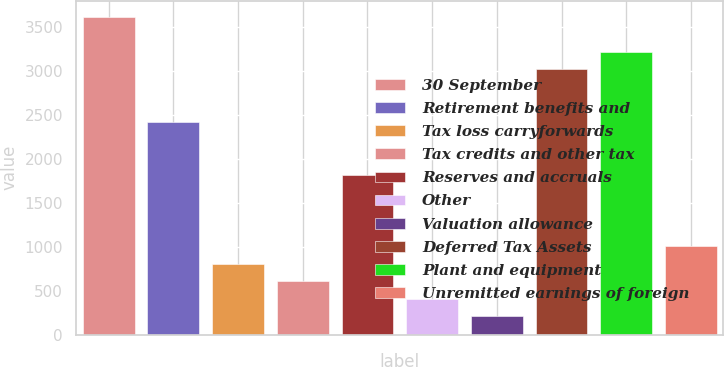Convert chart to OTSL. <chart><loc_0><loc_0><loc_500><loc_500><bar_chart><fcel>30 September<fcel>Retirement benefits and<fcel>Tax loss carryforwards<fcel>Tax credits and other tax<fcel>Reserves and accruals<fcel>Other<fcel>Valuation allowance<fcel>Deferred Tax Assets<fcel>Plant and equipment<fcel>Unremitted earnings of foreign<nl><fcel>3615.52<fcel>2412.88<fcel>809.36<fcel>608.92<fcel>1811.56<fcel>408.48<fcel>208.04<fcel>3014.2<fcel>3214.64<fcel>1009.8<nl></chart> 